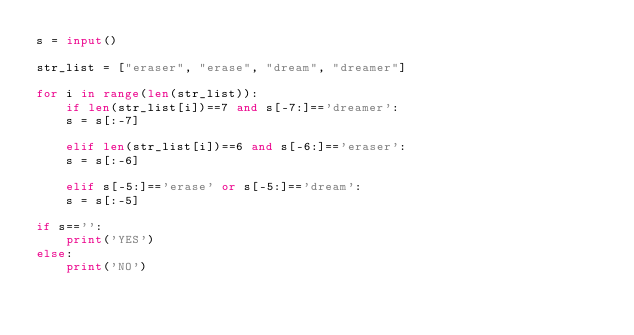Convert code to text. <code><loc_0><loc_0><loc_500><loc_500><_Python_>s = input()

str_list = ["eraser", "erase", "dream", "dreamer"]

for i in range(len(str_list)):
    if len(str_list[i])==7 and s[-7:]=='dreamer':
	s = s[:-7]

    elif len(str_list[i])==6 and s[-6:]=='eraser':
	s = s[:-6]
	
    elif s[-5:]=='erase' or s[-5:]=='dream':
	s = s[:-5]

if s=='':
    print('YES')
else:
    print('NO')</code> 